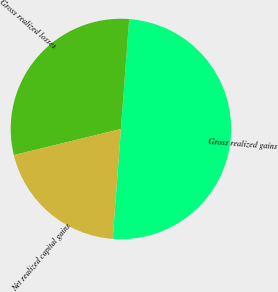Convert chart. <chart><loc_0><loc_0><loc_500><loc_500><pie_chart><fcel>Gross realized gains<fcel>Gross realized losses<fcel>Net realized capital gains<nl><fcel>50.0%<fcel>30.0%<fcel>20.0%<nl></chart> 